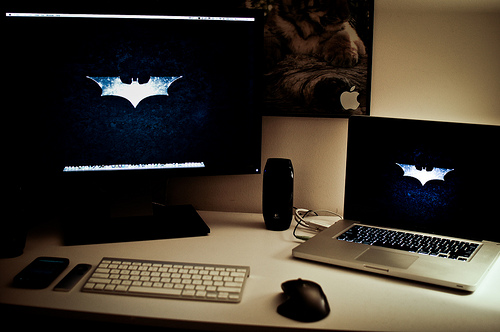<image>
Can you confirm if the mouse is next to the keyboard? Yes. The mouse is positioned adjacent to the keyboard, located nearby in the same general area. Is the logo on the laptop? No. The logo is not positioned on the laptop. They may be near each other, but the logo is not supported by or resting on top of the laptop. 